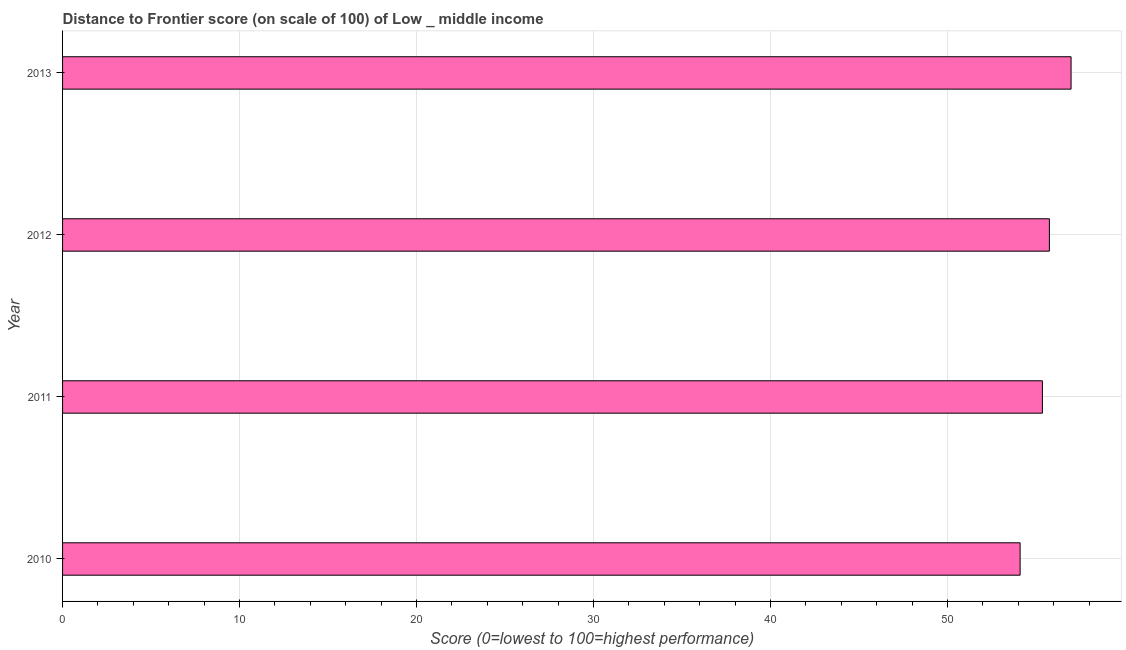Does the graph contain grids?
Your answer should be very brief. Yes. What is the title of the graph?
Make the answer very short. Distance to Frontier score (on scale of 100) of Low _ middle income. What is the label or title of the X-axis?
Your response must be concise. Score (0=lowest to 100=highest performance). What is the label or title of the Y-axis?
Make the answer very short. Year. What is the distance to frontier score in 2012?
Keep it short and to the point. 55.76. Across all years, what is the maximum distance to frontier score?
Your answer should be very brief. 56.98. Across all years, what is the minimum distance to frontier score?
Your answer should be compact. 54.1. In which year was the distance to frontier score maximum?
Give a very brief answer. 2013. In which year was the distance to frontier score minimum?
Keep it short and to the point. 2010. What is the sum of the distance to frontier score?
Your response must be concise. 222.21. What is the difference between the distance to frontier score in 2010 and 2012?
Your answer should be very brief. -1.65. What is the average distance to frontier score per year?
Keep it short and to the point. 55.55. What is the median distance to frontier score?
Keep it short and to the point. 55.56. Do a majority of the years between 2010 and 2013 (inclusive) have distance to frontier score greater than 22 ?
Provide a succinct answer. Yes. What is the ratio of the distance to frontier score in 2011 to that in 2012?
Provide a short and direct response. 0.99. Is the distance to frontier score in 2011 less than that in 2013?
Your response must be concise. Yes. Is the difference between the distance to frontier score in 2012 and 2013 greater than the difference between any two years?
Provide a short and direct response. No. What is the difference between the highest and the second highest distance to frontier score?
Offer a very short reply. 1.23. Is the sum of the distance to frontier score in 2010 and 2013 greater than the maximum distance to frontier score across all years?
Your answer should be very brief. Yes. What is the difference between the highest and the lowest distance to frontier score?
Your answer should be compact. 2.88. In how many years, is the distance to frontier score greater than the average distance to frontier score taken over all years?
Your answer should be very brief. 2. What is the Score (0=lowest to 100=highest performance) in 2010?
Offer a terse response. 54.1. What is the Score (0=lowest to 100=highest performance) in 2011?
Make the answer very short. 55.36. What is the Score (0=lowest to 100=highest performance) in 2012?
Offer a terse response. 55.76. What is the Score (0=lowest to 100=highest performance) in 2013?
Your response must be concise. 56.98. What is the difference between the Score (0=lowest to 100=highest performance) in 2010 and 2011?
Your answer should be very brief. -1.26. What is the difference between the Score (0=lowest to 100=highest performance) in 2010 and 2012?
Provide a short and direct response. -1.65. What is the difference between the Score (0=lowest to 100=highest performance) in 2010 and 2013?
Provide a succinct answer. -2.88. What is the difference between the Score (0=lowest to 100=highest performance) in 2011 and 2012?
Your answer should be compact. -0.4. What is the difference between the Score (0=lowest to 100=highest performance) in 2011 and 2013?
Give a very brief answer. -1.62. What is the difference between the Score (0=lowest to 100=highest performance) in 2012 and 2013?
Offer a very short reply. -1.23. What is the ratio of the Score (0=lowest to 100=highest performance) in 2010 to that in 2013?
Your response must be concise. 0.95. 